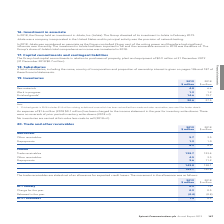According to Spirent Communications Plc's financial document, What does Finished goods in 2018 include? $1.8 million relating to deferred costs which has been reclassified from trade and other receivables. The document states: "Note 1. Finished goods in 2018 includes $1.8 million relating to deferred costs which has been reclassified from trade and other receivables; see note..." Also, What was charged to the income statement in the year for inventory write-downs? An expense of $1.6 million (2018 $0.1 million). The document states: "An expense of $1.6 million (2018 $0.1 million) has been charged to the income statement in the year for inventory write-downs. There were no revers..." Also, What are the types of inventories in the table? The document contains multiple relevant values: Raw materials, Work in progress, Finished goods. From the document: "Raw materials 4.8 6.6 Finished goods¹ 14.6 19.7 Work in progress 1.2 1.2..." Additionally, In which year was the amount of raw materials larger? According to the financial document, 2018. The relevant text states: "of $0.9 million at 31 December 2019 (31 December 2018 $0.7 million)...." Also, can you calculate: What was the change in total inventories? Based on the calculation: 20.6-27.5, the result is -6.9 (in millions). This is based on the information: "20.6 27.5 20.6 27.5..." The key data points involved are: 20.6, 27.5. Also, can you calculate: What was the percentage change in total inventories? To answer this question, I need to perform calculations using the financial data. The calculation is: (20.6-27.5)/27.5, which equals -25.09 (percentage). This is based on the information: "20.6 27.5 20.6 27.5..." The key data points involved are: 20.6, 27.5. 